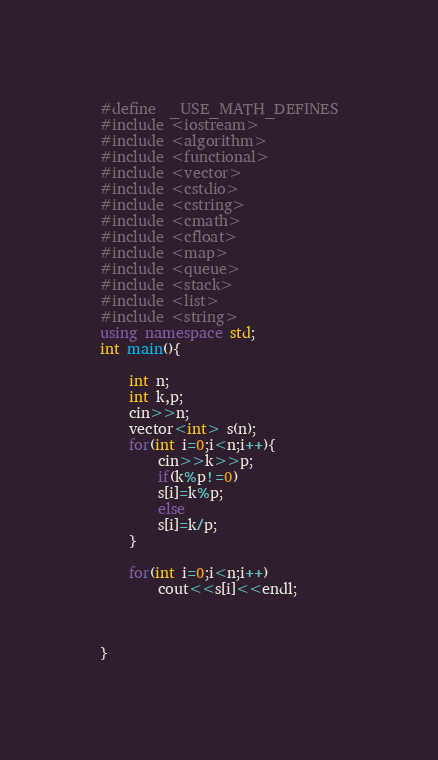<code> <loc_0><loc_0><loc_500><loc_500><_C++_>#define	_USE_MATH_DEFINES
#include <iostream>
#include <algorithm>
#include <functional>
#include <vector>
#include <cstdio>
#include <cstring>
#include <cmath>
#include <cfloat>
#include <map>
#include <queue>
#include <stack>
#include <list>
#include <string>
using namespace std;
int main(){
	
	int n;
	int k,p;
	cin>>n;
	vector<int> s(n);
	for(int i=0;i<n;i++){
		cin>>k>>p;
		if(k%p!=0)
		s[i]=k%p;
		else
		s[i]=k/p;
	}
	
	for(int i=0;i<n;i++)
		cout<<s[i]<<endl;
	
	

}</code> 